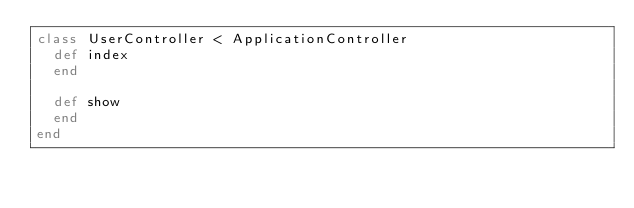<code> <loc_0><loc_0><loc_500><loc_500><_Ruby_>class UserController < ApplicationController
  def index
  end

  def show
  end
end
</code> 